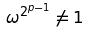Convert formula to latex. <formula><loc_0><loc_0><loc_500><loc_500>\omega ^ { 2 ^ { p - 1 } } \ne 1</formula> 